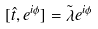<formula> <loc_0><loc_0><loc_500><loc_500>[ \hat { t } , e ^ { i \phi } ] = \tilde { \lambda } e ^ { i \phi }</formula> 